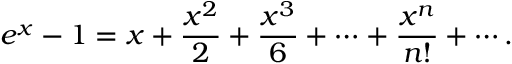Convert formula to latex. <formula><loc_0><loc_0><loc_500><loc_500>e ^ { x } - 1 = x + { \frac { x ^ { 2 } } { 2 } } + { \frac { x ^ { 3 } } { 6 } } + \cdots + { \frac { x ^ { n } } { n ! } } + \cdots .</formula> 